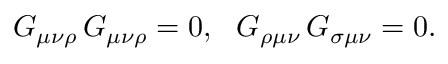Convert formula to latex. <formula><loc_0><loc_0><loc_500><loc_500>G _ { \mu \nu \rho } \, G _ { \mu \nu \rho } = 0 , \, G _ { \rho \mu \nu } \, G _ { \sigma \mu \nu } = 0 .</formula> 